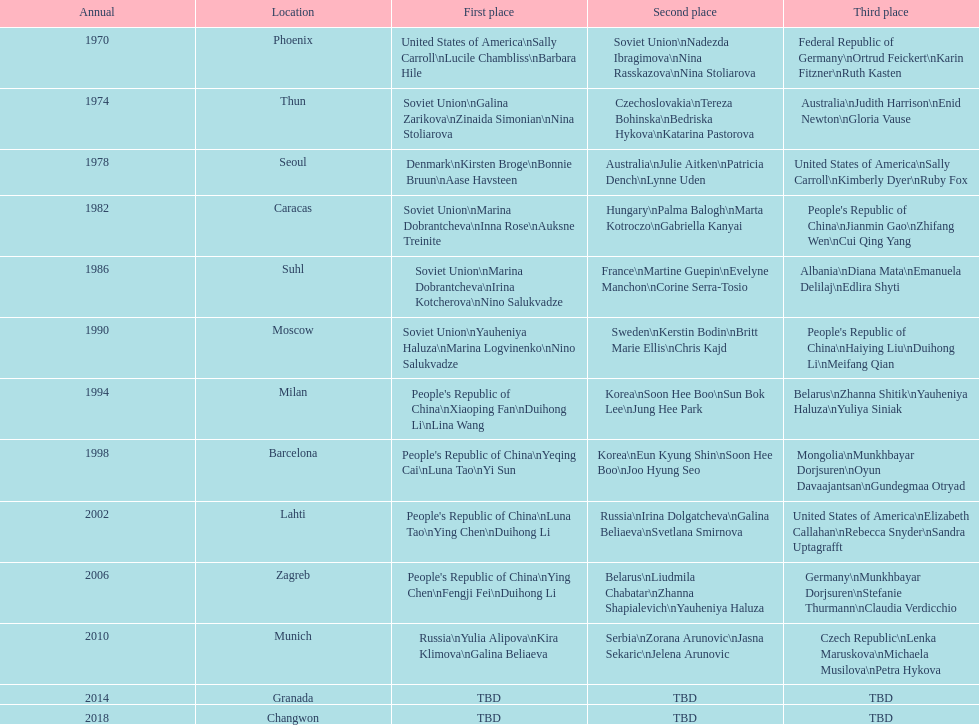What are the total number of times the soviet union is listed under the gold column? 4. 